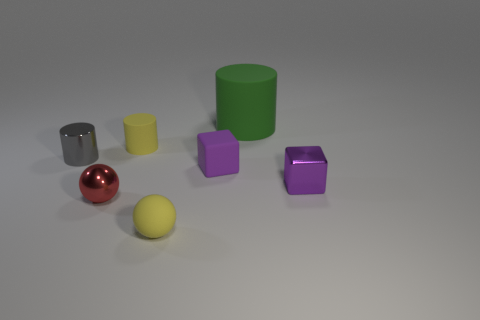There is a gray object that is the same size as the rubber ball; what shape is it?
Your answer should be compact. Cylinder. There is a rubber object that is the same color as the metallic block; what shape is it?
Your answer should be compact. Cube. Does the purple matte cube have the same size as the sphere that is right of the tiny red metallic ball?
Offer a terse response. Yes. What is the material of the big thing that is the same shape as the tiny gray metal thing?
Offer a terse response. Rubber. The thing that is behind the gray metallic thing and in front of the large rubber object has what shape?
Ensure brevity in your answer.  Cylinder. How many objects are big rubber things or tiny shiny objects in front of the tiny metallic block?
Keep it short and to the point. 2. Does the green cylinder have the same material as the yellow sphere?
Your answer should be compact. Yes. What number of other things are the same shape as the green matte object?
Your answer should be compact. 2. What size is the thing that is both behind the small gray cylinder and right of the small rubber sphere?
Give a very brief answer. Large. What number of metal objects are either small gray cylinders or spheres?
Ensure brevity in your answer.  2. 